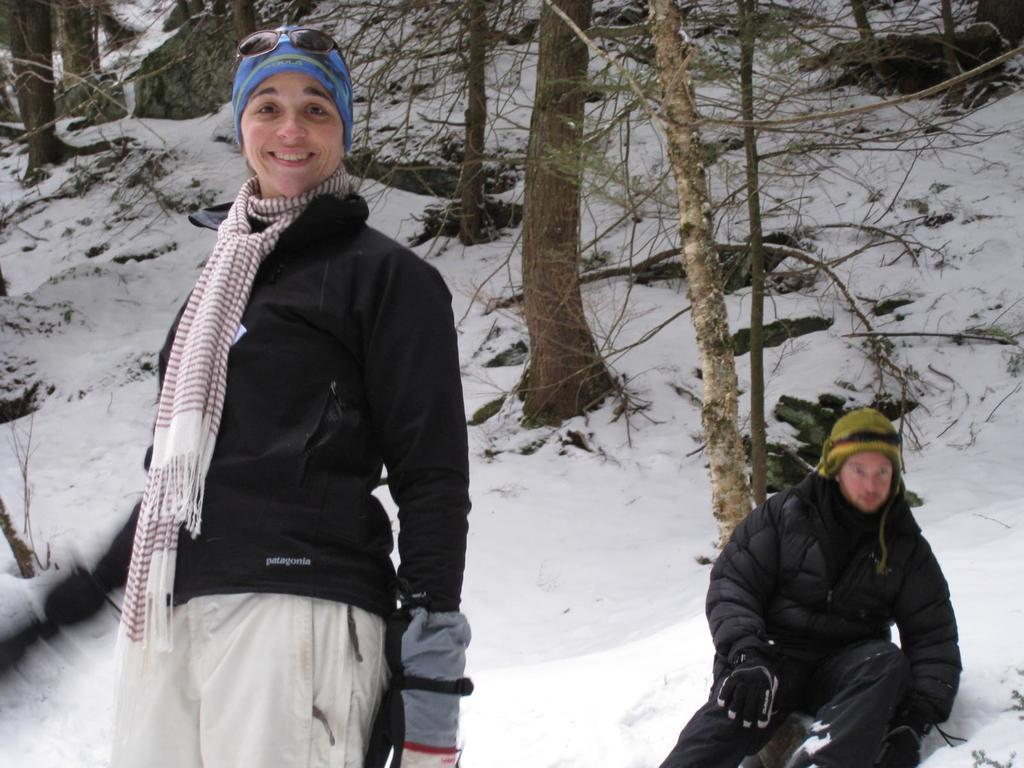What is the main element of the image? The image consists of ice. What can be seen in the middle and top of the image? There are trees in the middle and top of the image. How many people are in the image? There are two persons in the image. What clothing items are the persons wearing? The persons are wearing sweaters, caps, and gloves. What type of bubble can be seen in the image? There is no bubble present in the image; it consists of ice and trees. What kind of road can be seen in the image? There is no road visible in the image; it consists of ice and trees. 